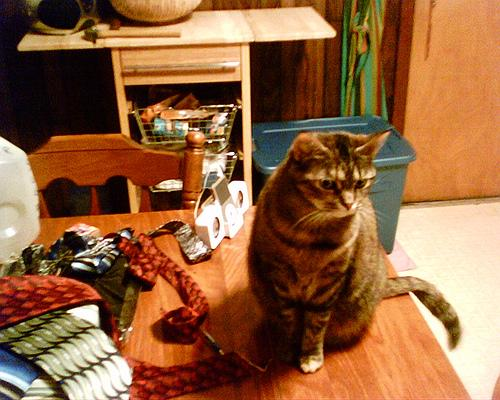Describe the scene in a minimalist, abstract way. Feline form, wooden surfaces, chair, table, distinct features. Create a children's book-style description of the image. Once upon a time, in a cozy little kitchen, a curious brown cat sat on a wooden table, with its big tail and tiny paw peeking out. Describe the image using onomatopoeia in your sentence. With a soft purr, the brown cat settles on the wooden table, its swishing tail and gentle paw-tap creating an enchanting melody in the quiet space. Craft a poetic description of the image. A gaze from eyes to whiskers conveyed. Describe the image as if you were an interior designer. This cozy kitchen scene features a wooden table and chair, with a charming brown cat as the focal point, adding to the warmth and inviting atmosphere. Write a sentence describing the image using a metaphor. Perched like royalty upon its wooden throne, the regal brown cat lounges gracefully, its tail and paw a testament to its feline splendor. Write a simple sentence describing the main focus of the image. A brown cat is sitting on a wooden table with its tail and paw visible. Write a single sentence using alliteration to describe the image. A captivating, curious cat sits calmly on a charming, wooden table, showcasing its striking tail and delicate paw. Describe the image as if you were narrating for a nature documentary. In this quaint domestic setting, a brown cat has found refuge upon a wooden table, its tail and paw exposed, as it surveys the surrounding environment. Describe the scene as if you are painting a mental image in someone's head. Picture a cozy kitchen scene: a warm, wooden table with a beautifully crafted chair nearby, and a brown cat sitting proudly in the spotlight, its long, fluffy tail and delicate paw visible for all to see. 